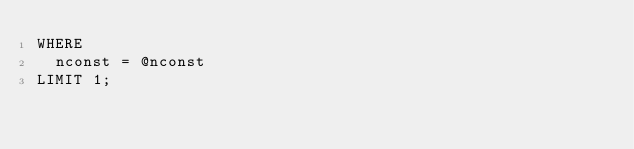Convert code to text. <code><loc_0><loc_0><loc_500><loc_500><_SQL_>WHERE
  nconst = @nconst
LIMIT 1;
</code> 